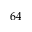Convert formula to latex. <formula><loc_0><loc_0><loc_500><loc_500>6 4</formula> 